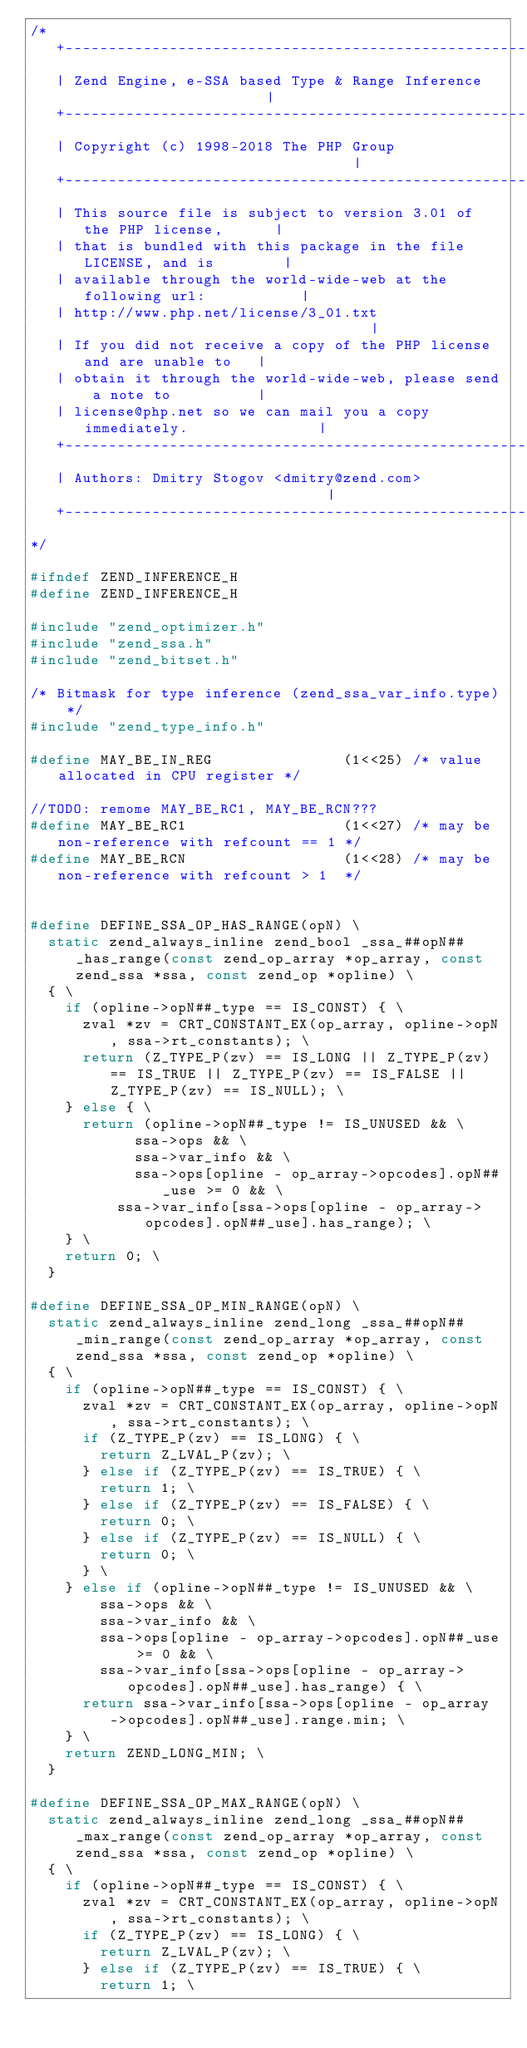Convert code to text. <code><loc_0><loc_0><loc_500><loc_500><_C_>/*
   +----------------------------------------------------------------------+
   | Zend Engine, e-SSA based Type & Range Inference                      |
   +----------------------------------------------------------------------+
   | Copyright (c) 1998-2018 The PHP Group                                |
   +----------------------------------------------------------------------+
   | This source file is subject to version 3.01 of the PHP license,      |
   | that is bundled with this package in the file LICENSE, and is        |
   | available through the world-wide-web at the following url:           |
   | http://www.php.net/license/3_01.txt                                  |
   | If you did not receive a copy of the PHP license and are unable to   |
   | obtain it through the world-wide-web, please send a note to          |
   | license@php.net so we can mail you a copy immediately.               |
   +----------------------------------------------------------------------+
   | Authors: Dmitry Stogov <dmitry@zend.com>                             |
   +----------------------------------------------------------------------+
*/

#ifndef ZEND_INFERENCE_H
#define ZEND_INFERENCE_H

#include "zend_optimizer.h"
#include "zend_ssa.h"
#include "zend_bitset.h"

/* Bitmask for type inference (zend_ssa_var_info.type) */
#include "zend_type_info.h"

#define MAY_BE_IN_REG               (1<<25) /* value allocated in CPU register */

//TODO: remome MAY_BE_RC1, MAY_BE_RCN???
#define MAY_BE_RC1                  (1<<27) /* may be non-reference with refcount == 1 */
#define MAY_BE_RCN                  (1<<28) /* may be non-reference with refcount > 1  */


#define DEFINE_SSA_OP_HAS_RANGE(opN) \
	static zend_always_inline zend_bool _ssa_##opN##_has_range(const zend_op_array *op_array, const zend_ssa *ssa, const zend_op *opline) \
	{ \
		if (opline->opN##_type == IS_CONST) { \
			zval *zv = CRT_CONSTANT_EX(op_array, opline->opN, ssa->rt_constants); \
			return (Z_TYPE_P(zv) == IS_LONG || Z_TYPE_P(zv) == IS_TRUE || Z_TYPE_P(zv) == IS_FALSE || Z_TYPE_P(zv) == IS_NULL); \
		} else { \
			return (opline->opN##_type != IS_UNUSED && \
		        ssa->ops && \
		        ssa->var_info && \
		        ssa->ops[opline - op_array->opcodes].opN##_use >= 0 && \
			    ssa->var_info[ssa->ops[opline - op_array->opcodes].opN##_use].has_range); \
		} \
		return 0; \
	}

#define DEFINE_SSA_OP_MIN_RANGE(opN) \
	static zend_always_inline zend_long _ssa_##opN##_min_range(const zend_op_array *op_array, const zend_ssa *ssa, const zend_op *opline) \
	{ \
		if (opline->opN##_type == IS_CONST) { \
			zval *zv = CRT_CONSTANT_EX(op_array, opline->opN, ssa->rt_constants); \
			if (Z_TYPE_P(zv) == IS_LONG) { \
				return Z_LVAL_P(zv); \
			} else if (Z_TYPE_P(zv) == IS_TRUE) { \
				return 1; \
			} else if (Z_TYPE_P(zv) == IS_FALSE) { \
				return 0; \
			} else if (Z_TYPE_P(zv) == IS_NULL) { \
				return 0; \
			} \
		} else if (opline->opN##_type != IS_UNUSED && \
		    ssa->ops && \
		    ssa->var_info && \
		    ssa->ops[opline - op_array->opcodes].opN##_use >= 0 && \
		    ssa->var_info[ssa->ops[opline - op_array->opcodes].opN##_use].has_range) { \
			return ssa->var_info[ssa->ops[opline - op_array->opcodes].opN##_use].range.min; \
		} \
		return ZEND_LONG_MIN; \
	}

#define DEFINE_SSA_OP_MAX_RANGE(opN) \
	static zend_always_inline zend_long _ssa_##opN##_max_range(const zend_op_array *op_array, const zend_ssa *ssa, const zend_op *opline) \
	{ \
		if (opline->opN##_type == IS_CONST) { \
			zval *zv = CRT_CONSTANT_EX(op_array, opline->opN, ssa->rt_constants); \
			if (Z_TYPE_P(zv) == IS_LONG) { \
				return Z_LVAL_P(zv); \
			} else if (Z_TYPE_P(zv) == IS_TRUE) { \
				return 1; \</code> 